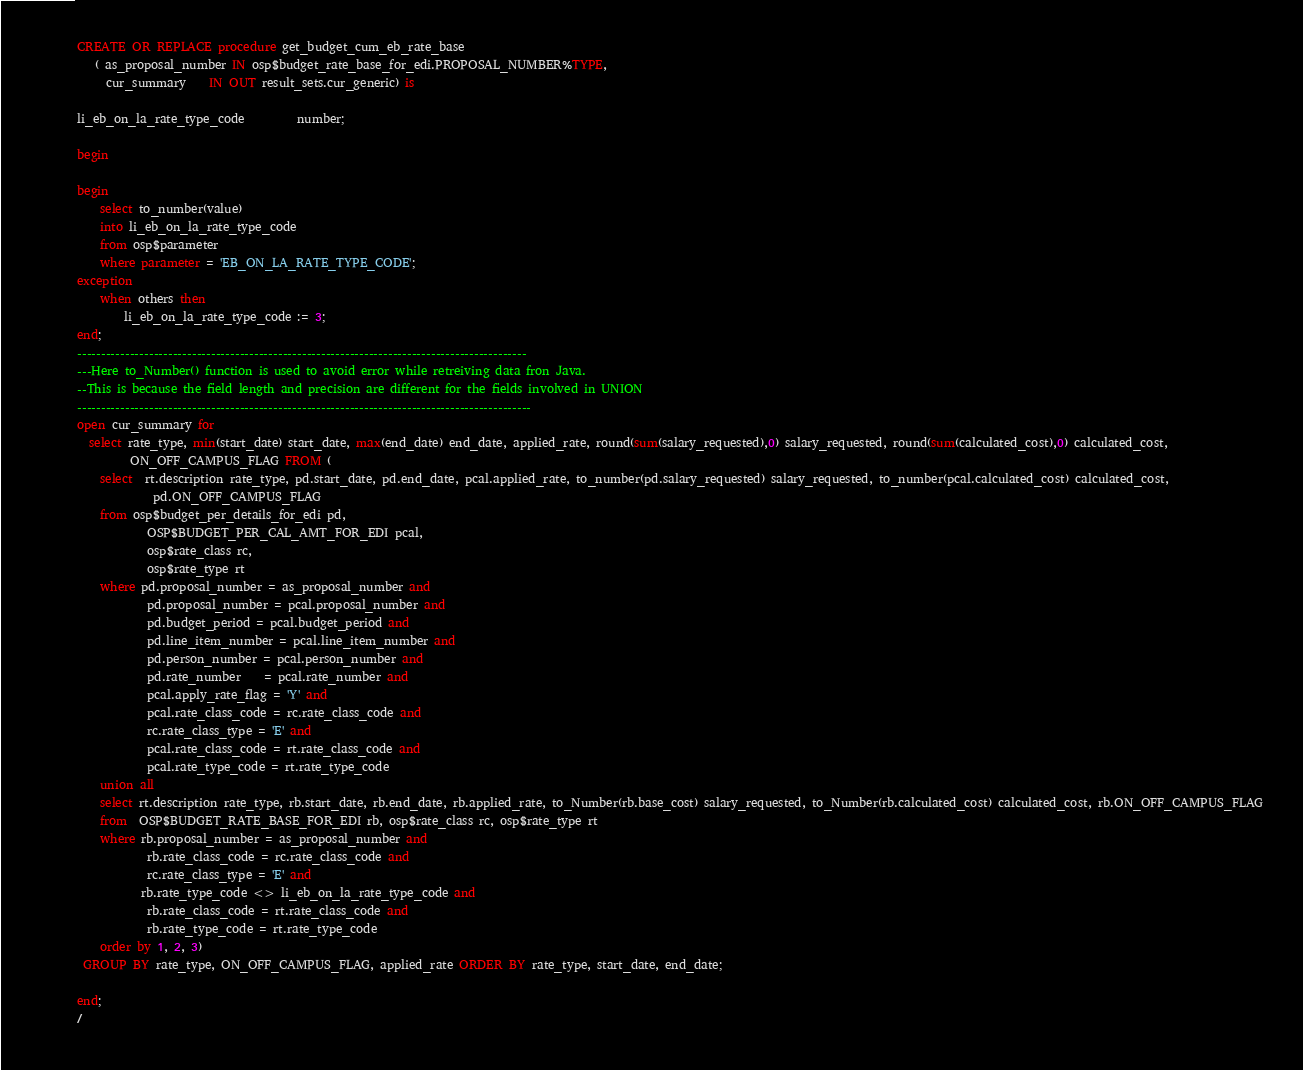<code> <loc_0><loc_0><loc_500><loc_500><_SQL_>CREATE OR REPLACE procedure get_budget_cum_eb_rate_base
   ( as_proposal_number IN osp$budget_rate_base_for_edi.PROPOSAL_NUMBER%TYPE,
     cur_summary 	IN OUT result_sets.cur_generic) is

li_eb_on_la_rate_type_code         number;

begin

begin
	select to_number(value)
	into li_eb_on_la_rate_type_code
	from osp$parameter
	where parameter = 'EB_ON_LA_RATE_TYPE_CODE';
exception
	when others then
		li_eb_on_la_rate_type_code := 3;
end;
----------------------------------------------------------------------------------------------
---Here to_Number() function is used to avoid error while retreiving data fron Java.
--This is because the field length and precision are different for the fields involved in UNION
-----------------------------------------------------------------------------------------------
open cur_summary for
  select rate_type, min(start_date) start_date, max(end_date) end_date, applied_rate, round(sum(salary_requested),0) salary_requested, round(sum(calculated_cost),0) calculated_cost,
		 ON_OFF_CAMPUS_FLAG FROM (
	select  rt.description rate_type, pd.start_date, pd.end_date, pcal.applied_rate, to_number(pd.salary_requested) salary_requested, to_number(pcal.calculated_cost) calculated_cost,
			 pd.ON_OFF_CAMPUS_FLAG
	from osp$budget_per_details_for_edi pd,
			OSP$BUDGET_PER_CAL_AMT_FOR_EDI pcal,
			osp$rate_class rc,
			osp$rate_type rt
	where pd.proposal_number = as_proposal_number and
			pd.proposal_number = pcal.proposal_number and
			pd.budget_period = pcal.budget_period and
			pd.line_item_number = pcal.line_item_number and
			pd.person_number = pcal.person_number and
			pd.rate_number	= pcal.rate_number and
			pcal.apply_rate_flag = 'Y' and
			pcal.rate_class_code = rc.rate_class_code and
			rc.rate_class_type = 'E' and
			pcal.rate_class_code = rt.rate_class_code and
			pcal.rate_type_code = rt.rate_type_code
	union all
	select rt.description rate_type, rb.start_date, rb.end_date, rb.applied_rate, to_Number(rb.base_cost) salary_requested, to_Number(rb.calculated_cost) calculated_cost, rb.ON_OFF_CAMPUS_FLAG
	from  OSP$BUDGET_RATE_BASE_FOR_EDI rb, osp$rate_class rc, osp$rate_type rt
	where rb.proposal_number = as_proposal_number and
			rb.rate_class_code = rc.rate_class_code and
			rc.rate_class_type = 'E' and
		   rb.rate_type_code <> li_eb_on_la_rate_type_code and
			rb.rate_class_code = rt.rate_class_code and
			rb.rate_type_code = rt.rate_type_code
	order by 1, 2, 3)
 GROUP BY rate_type, ON_OFF_CAMPUS_FLAG, applied_rate ORDER BY rate_type, start_date, end_date;

end;
/

</code> 